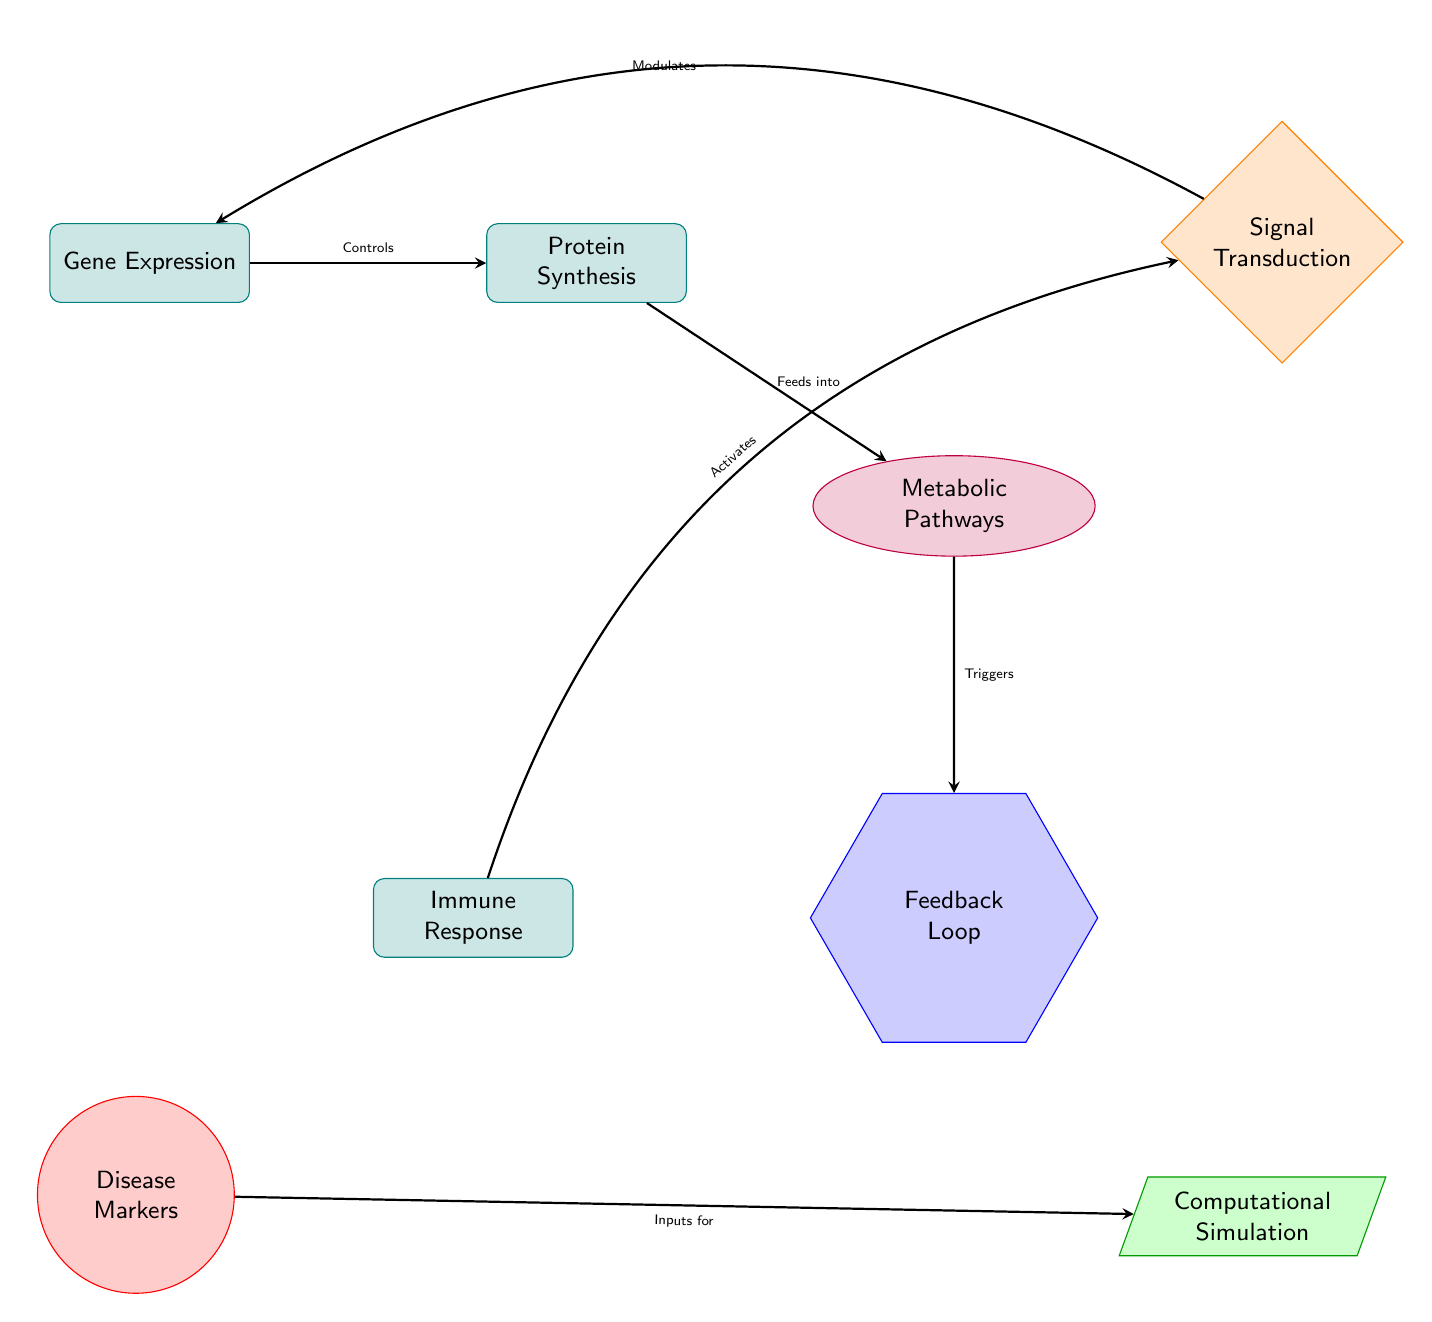What is the shape of the component that represents Gene Expression? The diagram shows that Gene Expression is a rectangle, which is used to represent components, as indicated by the 'component' style in the diagram legend.
Answer: rectangle What action does Protein Synthesis trigger? The arrow from Protein Synthesis to Metabolic Pathways signifies that Protein Synthesis feeds into Metabolic Pathways, indicating a sequential relationship where one process leads to another.
Answer: Feeds into How many components are depicted in the diagram? By counting the shapes labeled as components in the diagram, which are Gene Expression, Protein Synthesis, Immune Response, and Feedback Loop, we find there are four components.
Answer: 4 Which component modulates Gene Expression? The arrow pointing from Signal Transduction to Gene Expression, labeled as 'Modulates,' indicates that Signal Transduction has a modulatory effect on Gene Expression.
Answer: Signal Transduction What is the primary input for the Computational Simulation? The arrow from Disease Markers to Computational Simulation indicates that Disease Markers serve as inputs for Computational Simulation, establishing a direct relationship where Disease Markers influence the simulation.
Answer: Inputs for Explain the relationship between Immune Response and Signal Transduction. The diagram shows an arrow from Immune Response to Signal Transduction, along with a label that states 'Activates.' This indicates that the Immune Response has an activating role on the process of Signal Transduction, reflecting an interaction where one process stimulates another.
Answer: Activates What happens when Feedback Loop is triggered? The label 'Triggers' on the arrow connecting Metabolic Pathways to Feedback Loop suggests that once Metabolic Pathways are activated, they subsequently trigger the Feedback Loop, indicating a flow of influence that starts from one process and results in another.
Answer: Triggers Which two components are involved in the disease progression feedback loop? By identifying the components associated with feedback mechanisms, we see that both Metabolic Pathways and Feedback Loop are linked, as indicated by the directional arrows, which denote their interaction in the context of disease progression.
Answer: Metabolic Pathways and Feedback Loop 